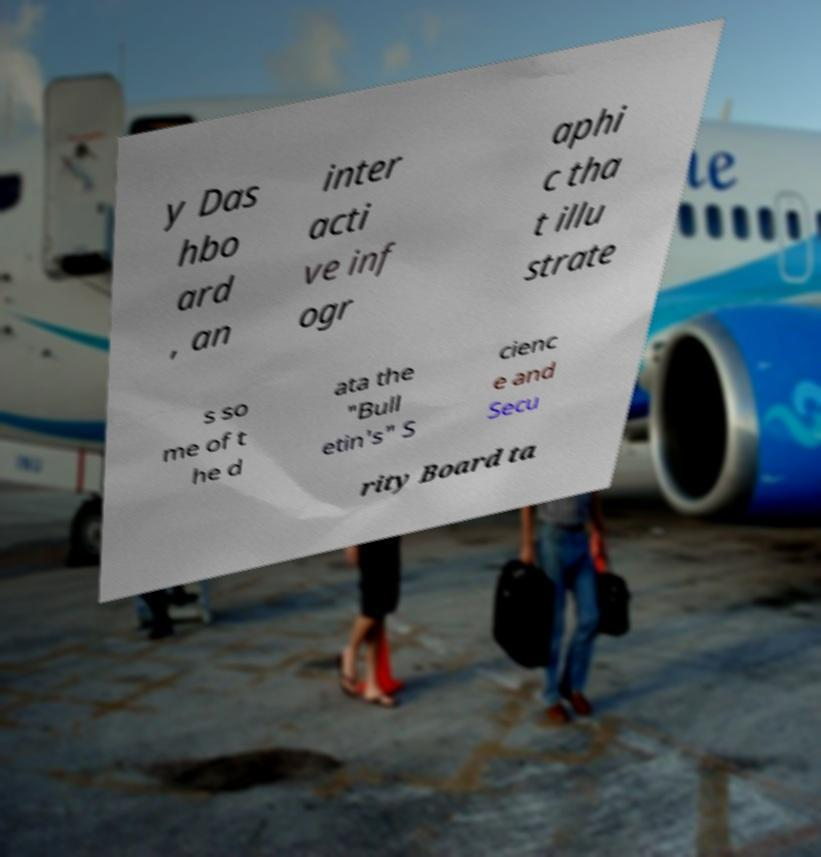Can you accurately transcribe the text from the provided image for me? y Das hbo ard , an inter acti ve inf ogr aphi c tha t illu strate s so me of t he d ata the "Bull etin's" S cienc e and Secu rity Board ta 